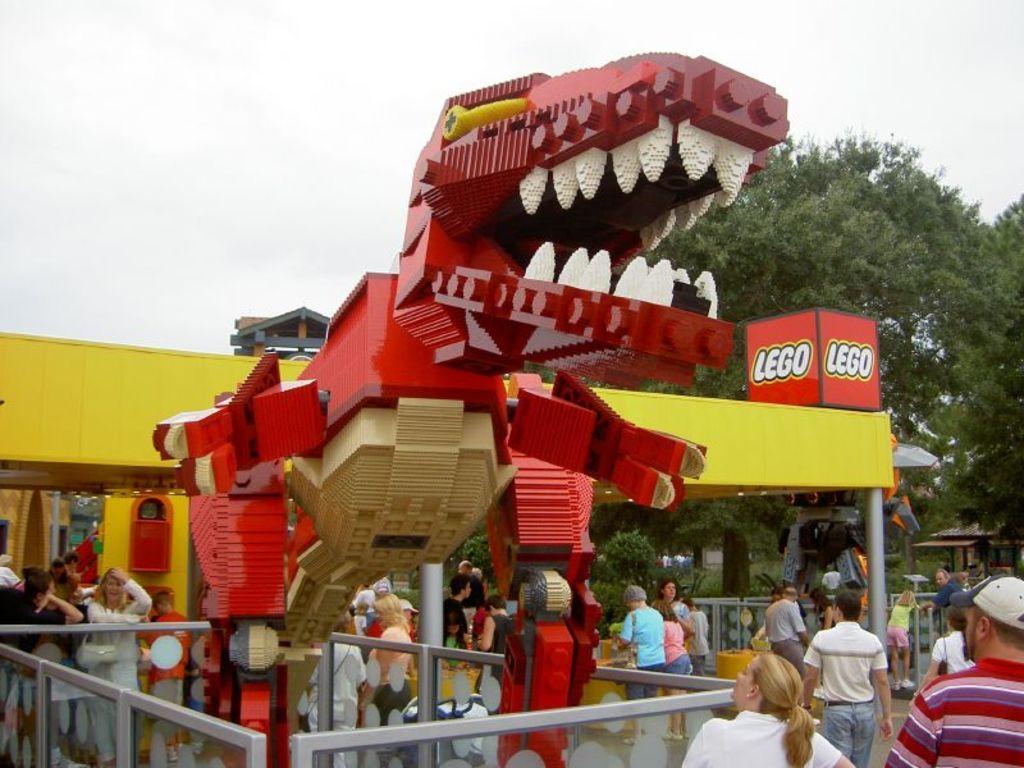Describe this image in one or two sentences. In this image in the middle, there is a dragon toy. At the bottom there are many people. In the middle there is a house, text and poster. In the background there are trees, people, houses and sky. 